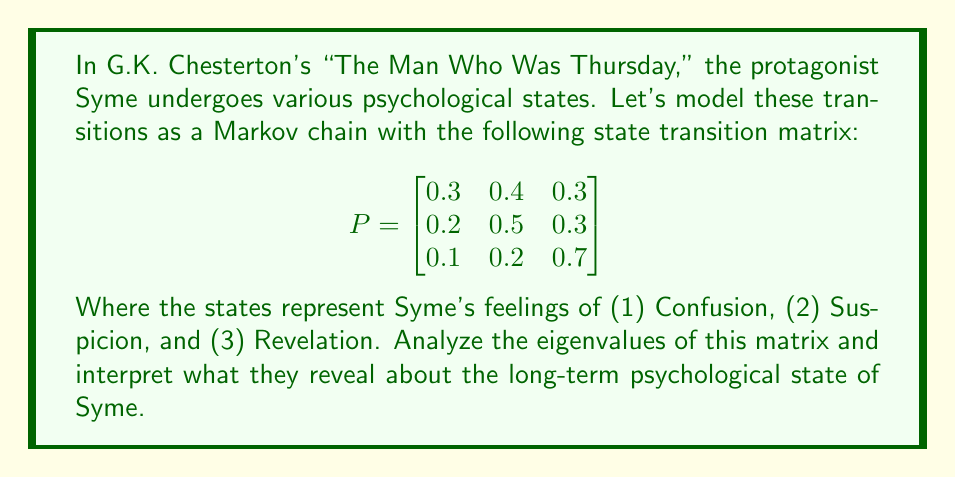Solve this math problem. To analyze the eigenvalues of the state transition matrix, we'll follow these steps:

1) First, we need to find the characteristic equation of the matrix P:
   $$det(P - \lambda I) = 0$$

2) Expanding this determinant:
   $$\begin{vmatrix}
   0.3 - \lambda & 0.4 & 0.3 \\
   0.2 & 0.5 - \lambda & 0.3 \\
   0.1 & 0.2 & 0.7 - \lambda
   \end{vmatrix} = 0$$

3) Calculating the determinant:
   $$(0.3 - \lambda)[(0.5 - \lambda)(0.7 - \lambda) - 0.06] - 0.4[0.2(0.7 - \lambda) - 0.03] + 0.3[0.2(0.5 - \lambda) - 0.06] = 0$$

4) Simplifying:
   $$-\lambda^3 + 1.5\lambda^2 - 0.47\lambda + 0 = 0$$

5) The roots of this equation are the eigenvalues. Using the cubic formula or numerical methods, we find:
   $$\lambda_1 = 1, \lambda_2 \approx 0.3858, \lambda_3 \approx 0.1142$$

6) Interpreting these eigenvalues:
   - $\lambda_1 = 1$ is the dominant eigenvalue, which always exists for stochastic matrices.
   - The magnitude of $\lambda_2$ and $\lambda_3$ being less than 1 indicates that the system will converge to a stable distribution.
   - The rate of convergence is determined by the second largest eigenvalue in magnitude, $\lambda_2 \approx 0.3858$.

7) In the context of Syme's psychological states:
   - The existence of $\lambda_1 = 1$ suggests that Syme will eventually settle into a stable psychological state distribution.
   - The value of $\lambda_2 \approx 0.3858$ indicates a moderately fast convergence to this stable state, reflecting the psychological complexity and frequent state transitions in Chesterton's narrative.
   - The small value of $\lambda_3 \approx 0.1142$ suggests that one component of Syme's psychological state decays very quickly, possibly representing the rapid resolution of initial confusion in the face of new revelations.
Answer: Eigenvalues: 1, 0.3858, 0.1142. Stable long-term psychological state with moderately fast convergence. 